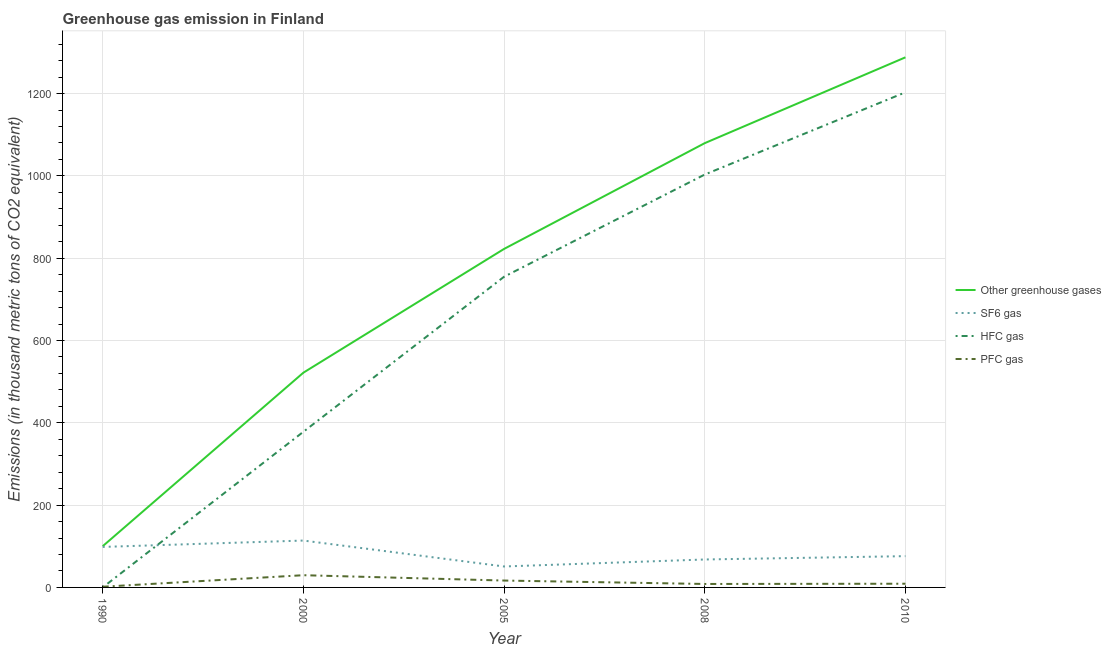What is the emission of pfc gas in 2000?
Provide a succinct answer. 29.7. Across all years, what is the maximum emission of hfc gas?
Your response must be concise. 1203. Across all years, what is the minimum emission of greenhouse gases?
Give a very brief answer. 100.2. What is the total emission of greenhouse gases in the graph?
Ensure brevity in your answer.  3812. What is the difference between the emission of pfc gas in 2000 and that in 2008?
Provide a short and direct response. 21.3. What is the difference between the emission of greenhouse gases in 2005 and the emission of pfc gas in 2008?
Keep it short and to the point. 814.1. In the year 1990, what is the difference between the emission of hfc gas and emission of pfc gas?
Provide a succinct answer. -1.6. What is the ratio of the emission of hfc gas in 1990 to that in 2008?
Your response must be concise. 9.968102073365231e-5. What is the difference between the highest and the second highest emission of greenhouse gases?
Give a very brief answer. 208.5. What is the difference between the highest and the lowest emission of hfc gas?
Provide a short and direct response. 1202.9. In how many years, is the emission of hfc gas greater than the average emission of hfc gas taken over all years?
Offer a terse response. 3. Is it the case that in every year, the sum of the emission of greenhouse gases and emission of sf6 gas is greater than the emission of hfc gas?
Your answer should be compact. Yes. Does the emission of pfc gas monotonically increase over the years?
Keep it short and to the point. No. Is the emission of pfc gas strictly less than the emission of sf6 gas over the years?
Ensure brevity in your answer.  Yes. How many years are there in the graph?
Your answer should be very brief. 5. Where does the legend appear in the graph?
Your answer should be very brief. Center right. How many legend labels are there?
Your answer should be compact. 4. What is the title of the graph?
Ensure brevity in your answer.  Greenhouse gas emission in Finland. What is the label or title of the Y-axis?
Offer a very short reply. Emissions (in thousand metric tons of CO2 equivalent). What is the Emissions (in thousand metric tons of CO2 equivalent) of Other greenhouse gases in 1990?
Provide a short and direct response. 100.2. What is the Emissions (in thousand metric tons of CO2 equivalent) of SF6 gas in 1990?
Give a very brief answer. 98.4. What is the Emissions (in thousand metric tons of CO2 equivalent) in Other greenhouse gases in 2000?
Ensure brevity in your answer.  521.8. What is the Emissions (in thousand metric tons of CO2 equivalent) in SF6 gas in 2000?
Make the answer very short. 113.9. What is the Emissions (in thousand metric tons of CO2 equivalent) in HFC gas in 2000?
Give a very brief answer. 378.2. What is the Emissions (in thousand metric tons of CO2 equivalent) of PFC gas in 2000?
Your response must be concise. 29.7. What is the Emissions (in thousand metric tons of CO2 equivalent) in Other greenhouse gases in 2005?
Offer a very short reply. 822.5. What is the Emissions (in thousand metric tons of CO2 equivalent) in SF6 gas in 2005?
Your answer should be compact. 50.9. What is the Emissions (in thousand metric tons of CO2 equivalent) in HFC gas in 2005?
Provide a succinct answer. 754.9. What is the Emissions (in thousand metric tons of CO2 equivalent) in PFC gas in 2005?
Keep it short and to the point. 16.7. What is the Emissions (in thousand metric tons of CO2 equivalent) in Other greenhouse gases in 2008?
Provide a short and direct response. 1079.5. What is the Emissions (in thousand metric tons of CO2 equivalent) in SF6 gas in 2008?
Offer a very short reply. 67.9. What is the Emissions (in thousand metric tons of CO2 equivalent) of HFC gas in 2008?
Provide a succinct answer. 1003.2. What is the Emissions (in thousand metric tons of CO2 equivalent) of PFC gas in 2008?
Ensure brevity in your answer.  8.4. What is the Emissions (in thousand metric tons of CO2 equivalent) of Other greenhouse gases in 2010?
Your answer should be very brief. 1288. What is the Emissions (in thousand metric tons of CO2 equivalent) in SF6 gas in 2010?
Give a very brief answer. 76. What is the Emissions (in thousand metric tons of CO2 equivalent) in HFC gas in 2010?
Keep it short and to the point. 1203. What is the Emissions (in thousand metric tons of CO2 equivalent) of PFC gas in 2010?
Provide a short and direct response. 9. Across all years, what is the maximum Emissions (in thousand metric tons of CO2 equivalent) of Other greenhouse gases?
Provide a short and direct response. 1288. Across all years, what is the maximum Emissions (in thousand metric tons of CO2 equivalent) of SF6 gas?
Provide a short and direct response. 113.9. Across all years, what is the maximum Emissions (in thousand metric tons of CO2 equivalent) in HFC gas?
Ensure brevity in your answer.  1203. Across all years, what is the maximum Emissions (in thousand metric tons of CO2 equivalent) of PFC gas?
Keep it short and to the point. 29.7. Across all years, what is the minimum Emissions (in thousand metric tons of CO2 equivalent) in Other greenhouse gases?
Offer a very short reply. 100.2. Across all years, what is the minimum Emissions (in thousand metric tons of CO2 equivalent) of SF6 gas?
Ensure brevity in your answer.  50.9. Across all years, what is the minimum Emissions (in thousand metric tons of CO2 equivalent) in HFC gas?
Offer a terse response. 0.1. What is the total Emissions (in thousand metric tons of CO2 equivalent) in Other greenhouse gases in the graph?
Your answer should be compact. 3812. What is the total Emissions (in thousand metric tons of CO2 equivalent) of SF6 gas in the graph?
Your response must be concise. 407.1. What is the total Emissions (in thousand metric tons of CO2 equivalent) of HFC gas in the graph?
Ensure brevity in your answer.  3339.4. What is the total Emissions (in thousand metric tons of CO2 equivalent) of PFC gas in the graph?
Your answer should be compact. 65.5. What is the difference between the Emissions (in thousand metric tons of CO2 equivalent) in Other greenhouse gases in 1990 and that in 2000?
Offer a very short reply. -421.6. What is the difference between the Emissions (in thousand metric tons of CO2 equivalent) of SF6 gas in 1990 and that in 2000?
Offer a terse response. -15.5. What is the difference between the Emissions (in thousand metric tons of CO2 equivalent) of HFC gas in 1990 and that in 2000?
Provide a succinct answer. -378.1. What is the difference between the Emissions (in thousand metric tons of CO2 equivalent) in PFC gas in 1990 and that in 2000?
Offer a terse response. -28. What is the difference between the Emissions (in thousand metric tons of CO2 equivalent) of Other greenhouse gases in 1990 and that in 2005?
Offer a very short reply. -722.3. What is the difference between the Emissions (in thousand metric tons of CO2 equivalent) of SF6 gas in 1990 and that in 2005?
Offer a very short reply. 47.5. What is the difference between the Emissions (in thousand metric tons of CO2 equivalent) of HFC gas in 1990 and that in 2005?
Provide a succinct answer. -754.8. What is the difference between the Emissions (in thousand metric tons of CO2 equivalent) of Other greenhouse gases in 1990 and that in 2008?
Offer a very short reply. -979.3. What is the difference between the Emissions (in thousand metric tons of CO2 equivalent) in SF6 gas in 1990 and that in 2008?
Ensure brevity in your answer.  30.5. What is the difference between the Emissions (in thousand metric tons of CO2 equivalent) of HFC gas in 1990 and that in 2008?
Your response must be concise. -1003.1. What is the difference between the Emissions (in thousand metric tons of CO2 equivalent) in PFC gas in 1990 and that in 2008?
Give a very brief answer. -6.7. What is the difference between the Emissions (in thousand metric tons of CO2 equivalent) of Other greenhouse gases in 1990 and that in 2010?
Your answer should be compact. -1187.8. What is the difference between the Emissions (in thousand metric tons of CO2 equivalent) of SF6 gas in 1990 and that in 2010?
Provide a short and direct response. 22.4. What is the difference between the Emissions (in thousand metric tons of CO2 equivalent) of HFC gas in 1990 and that in 2010?
Keep it short and to the point. -1202.9. What is the difference between the Emissions (in thousand metric tons of CO2 equivalent) in Other greenhouse gases in 2000 and that in 2005?
Give a very brief answer. -300.7. What is the difference between the Emissions (in thousand metric tons of CO2 equivalent) of SF6 gas in 2000 and that in 2005?
Your answer should be very brief. 63. What is the difference between the Emissions (in thousand metric tons of CO2 equivalent) of HFC gas in 2000 and that in 2005?
Offer a very short reply. -376.7. What is the difference between the Emissions (in thousand metric tons of CO2 equivalent) of Other greenhouse gases in 2000 and that in 2008?
Provide a short and direct response. -557.7. What is the difference between the Emissions (in thousand metric tons of CO2 equivalent) of HFC gas in 2000 and that in 2008?
Your response must be concise. -625. What is the difference between the Emissions (in thousand metric tons of CO2 equivalent) in PFC gas in 2000 and that in 2008?
Offer a terse response. 21.3. What is the difference between the Emissions (in thousand metric tons of CO2 equivalent) of Other greenhouse gases in 2000 and that in 2010?
Give a very brief answer. -766.2. What is the difference between the Emissions (in thousand metric tons of CO2 equivalent) of SF6 gas in 2000 and that in 2010?
Your response must be concise. 37.9. What is the difference between the Emissions (in thousand metric tons of CO2 equivalent) in HFC gas in 2000 and that in 2010?
Give a very brief answer. -824.8. What is the difference between the Emissions (in thousand metric tons of CO2 equivalent) of PFC gas in 2000 and that in 2010?
Your answer should be compact. 20.7. What is the difference between the Emissions (in thousand metric tons of CO2 equivalent) of Other greenhouse gases in 2005 and that in 2008?
Your answer should be very brief. -257. What is the difference between the Emissions (in thousand metric tons of CO2 equivalent) of HFC gas in 2005 and that in 2008?
Your answer should be compact. -248.3. What is the difference between the Emissions (in thousand metric tons of CO2 equivalent) in PFC gas in 2005 and that in 2008?
Provide a short and direct response. 8.3. What is the difference between the Emissions (in thousand metric tons of CO2 equivalent) in Other greenhouse gases in 2005 and that in 2010?
Ensure brevity in your answer.  -465.5. What is the difference between the Emissions (in thousand metric tons of CO2 equivalent) in SF6 gas in 2005 and that in 2010?
Your answer should be compact. -25.1. What is the difference between the Emissions (in thousand metric tons of CO2 equivalent) of HFC gas in 2005 and that in 2010?
Offer a terse response. -448.1. What is the difference between the Emissions (in thousand metric tons of CO2 equivalent) of PFC gas in 2005 and that in 2010?
Provide a short and direct response. 7.7. What is the difference between the Emissions (in thousand metric tons of CO2 equivalent) in Other greenhouse gases in 2008 and that in 2010?
Your answer should be very brief. -208.5. What is the difference between the Emissions (in thousand metric tons of CO2 equivalent) of HFC gas in 2008 and that in 2010?
Offer a very short reply. -199.8. What is the difference between the Emissions (in thousand metric tons of CO2 equivalent) in PFC gas in 2008 and that in 2010?
Give a very brief answer. -0.6. What is the difference between the Emissions (in thousand metric tons of CO2 equivalent) of Other greenhouse gases in 1990 and the Emissions (in thousand metric tons of CO2 equivalent) of SF6 gas in 2000?
Offer a terse response. -13.7. What is the difference between the Emissions (in thousand metric tons of CO2 equivalent) of Other greenhouse gases in 1990 and the Emissions (in thousand metric tons of CO2 equivalent) of HFC gas in 2000?
Your answer should be compact. -278. What is the difference between the Emissions (in thousand metric tons of CO2 equivalent) of Other greenhouse gases in 1990 and the Emissions (in thousand metric tons of CO2 equivalent) of PFC gas in 2000?
Provide a succinct answer. 70.5. What is the difference between the Emissions (in thousand metric tons of CO2 equivalent) in SF6 gas in 1990 and the Emissions (in thousand metric tons of CO2 equivalent) in HFC gas in 2000?
Your answer should be compact. -279.8. What is the difference between the Emissions (in thousand metric tons of CO2 equivalent) in SF6 gas in 1990 and the Emissions (in thousand metric tons of CO2 equivalent) in PFC gas in 2000?
Ensure brevity in your answer.  68.7. What is the difference between the Emissions (in thousand metric tons of CO2 equivalent) in HFC gas in 1990 and the Emissions (in thousand metric tons of CO2 equivalent) in PFC gas in 2000?
Provide a succinct answer. -29.6. What is the difference between the Emissions (in thousand metric tons of CO2 equivalent) of Other greenhouse gases in 1990 and the Emissions (in thousand metric tons of CO2 equivalent) of SF6 gas in 2005?
Provide a short and direct response. 49.3. What is the difference between the Emissions (in thousand metric tons of CO2 equivalent) in Other greenhouse gases in 1990 and the Emissions (in thousand metric tons of CO2 equivalent) in HFC gas in 2005?
Your response must be concise. -654.7. What is the difference between the Emissions (in thousand metric tons of CO2 equivalent) of Other greenhouse gases in 1990 and the Emissions (in thousand metric tons of CO2 equivalent) of PFC gas in 2005?
Offer a terse response. 83.5. What is the difference between the Emissions (in thousand metric tons of CO2 equivalent) in SF6 gas in 1990 and the Emissions (in thousand metric tons of CO2 equivalent) in HFC gas in 2005?
Offer a terse response. -656.5. What is the difference between the Emissions (in thousand metric tons of CO2 equivalent) of SF6 gas in 1990 and the Emissions (in thousand metric tons of CO2 equivalent) of PFC gas in 2005?
Make the answer very short. 81.7. What is the difference between the Emissions (in thousand metric tons of CO2 equivalent) in HFC gas in 1990 and the Emissions (in thousand metric tons of CO2 equivalent) in PFC gas in 2005?
Your answer should be compact. -16.6. What is the difference between the Emissions (in thousand metric tons of CO2 equivalent) in Other greenhouse gases in 1990 and the Emissions (in thousand metric tons of CO2 equivalent) in SF6 gas in 2008?
Offer a very short reply. 32.3. What is the difference between the Emissions (in thousand metric tons of CO2 equivalent) in Other greenhouse gases in 1990 and the Emissions (in thousand metric tons of CO2 equivalent) in HFC gas in 2008?
Provide a succinct answer. -903. What is the difference between the Emissions (in thousand metric tons of CO2 equivalent) of Other greenhouse gases in 1990 and the Emissions (in thousand metric tons of CO2 equivalent) of PFC gas in 2008?
Your response must be concise. 91.8. What is the difference between the Emissions (in thousand metric tons of CO2 equivalent) of SF6 gas in 1990 and the Emissions (in thousand metric tons of CO2 equivalent) of HFC gas in 2008?
Provide a succinct answer. -904.8. What is the difference between the Emissions (in thousand metric tons of CO2 equivalent) of HFC gas in 1990 and the Emissions (in thousand metric tons of CO2 equivalent) of PFC gas in 2008?
Keep it short and to the point. -8.3. What is the difference between the Emissions (in thousand metric tons of CO2 equivalent) of Other greenhouse gases in 1990 and the Emissions (in thousand metric tons of CO2 equivalent) of SF6 gas in 2010?
Offer a very short reply. 24.2. What is the difference between the Emissions (in thousand metric tons of CO2 equivalent) in Other greenhouse gases in 1990 and the Emissions (in thousand metric tons of CO2 equivalent) in HFC gas in 2010?
Offer a terse response. -1102.8. What is the difference between the Emissions (in thousand metric tons of CO2 equivalent) of Other greenhouse gases in 1990 and the Emissions (in thousand metric tons of CO2 equivalent) of PFC gas in 2010?
Provide a succinct answer. 91.2. What is the difference between the Emissions (in thousand metric tons of CO2 equivalent) of SF6 gas in 1990 and the Emissions (in thousand metric tons of CO2 equivalent) of HFC gas in 2010?
Give a very brief answer. -1104.6. What is the difference between the Emissions (in thousand metric tons of CO2 equivalent) in SF6 gas in 1990 and the Emissions (in thousand metric tons of CO2 equivalent) in PFC gas in 2010?
Your answer should be compact. 89.4. What is the difference between the Emissions (in thousand metric tons of CO2 equivalent) in HFC gas in 1990 and the Emissions (in thousand metric tons of CO2 equivalent) in PFC gas in 2010?
Your answer should be very brief. -8.9. What is the difference between the Emissions (in thousand metric tons of CO2 equivalent) in Other greenhouse gases in 2000 and the Emissions (in thousand metric tons of CO2 equivalent) in SF6 gas in 2005?
Offer a terse response. 470.9. What is the difference between the Emissions (in thousand metric tons of CO2 equivalent) in Other greenhouse gases in 2000 and the Emissions (in thousand metric tons of CO2 equivalent) in HFC gas in 2005?
Ensure brevity in your answer.  -233.1. What is the difference between the Emissions (in thousand metric tons of CO2 equivalent) in Other greenhouse gases in 2000 and the Emissions (in thousand metric tons of CO2 equivalent) in PFC gas in 2005?
Make the answer very short. 505.1. What is the difference between the Emissions (in thousand metric tons of CO2 equivalent) of SF6 gas in 2000 and the Emissions (in thousand metric tons of CO2 equivalent) of HFC gas in 2005?
Provide a succinct answer. -641. What is the difference between the Emissions (in thousand metric tons of CO2 equivalent) in SF6 gas in 2000 and the Emissions (in thousand metric tons of CO2 equivalent) in PFC gas in 2005?
Offer a very short reply. 97.2. What is the difference between the Emissions (in thousand metric tons of CO2 equivalent) in HFC gas in 2000 and the Emissions (in thousand metric tons of CO2 equivalent) in PFC gas in 2005?
Make the answer very short. 361.5. What is the difference between the Emissions (in thousand metric tons of CO2 equivalent) of Other greenhouse gases in 2000 and the Emissions (in thousand metric tons of CO2 equivalent) of SF6 gas in 2008?
Make the answer very short. 453.9. What is the difference between the Emissions (in thousand metric tons of CO2 equivalent) in Other greenhouse gases in 2000 and the Emissions (in thousand metric tons of CO2 equivalent) in HFC gas in 2008?
Ensure brevity in your answer.  -481.4. What is the difference between the Emissions (in thousand metric tons of CO2 equivalent) in Other greenhouse gases in 2000 and the Emissions (in thousand metric tons of CO2 equivalent) in PFC gas in 2008?
Offer a very short reply. 513.4. What is the difference between the Emissions (in thousand metric tons of CO2 equivalent) in SF6 gas in 2000 and the Emissions (in thousand metric tons of CO2 equivalent) in HFC gas in 2008?
Your answer should be very brief. -889.3. What is the difference between the Emissions (in thousand metric tons of CO2 equivalent) in SF6 gas in 2000 and the Emissions (in thousand metric tons of CO2 equivalent) in PFC gas in 2008?
Your response must be concise. 105.5. What is the difference between the Emissions (in thousand metric tons of CO2 equivalent) of HFC gas in 2000 and the Emissions (in thousand metric tons of CO2 equivalent) of PFC gas in 2008?
Give a very brief answer. 369.8. What is the difference between the Emissions (in thousand metric tons of CO2 equivalent) in Other greenhouse gases in 2000 and the Emissions (in thousand metric tons of CO2 equivalent) in SF6 gas in 2010?
Ensure brevity in your answer.  445.8. What is the difference between the Emissions (in thousand metric tons of CO2 equivalent) in Other greenhouse gases in 2000 and the Emissions (in thousand metric tons of CO2 equivalent) in HFC gas in 2010?
Your answer should be very brief. -681.2. What is the difference between the Emissions (in thousand metric tons of CO2 equivalent) in Other greenhouse gases in 2000 and the Emissions (in thousand metric tons of CO2 equivalent) in PFC gas in 2010?
Offer a very short reply. 512.8. What is the difference between the Emissions (in thousand metric tons of CO2 equivalent) of SF6 gas in 2000 and the Emissions (in thousand metric tons of CO2 equivalent) of HFC gas in 2010?
Make the answer very short. -1089.1. What is the difference between the Emissions (in thousand metric tons of CO2 equivalent) of SF6 gas in 2000 and the Emissions (in thousand metric tons of CO2 equivalent) of PFC gas in 2010?
Ensure brevity in your answer.  104.9. What is the difference between the Emissions (in thousand metric tons of CO2 equivalent) of HFC gas in 2000 and the Emissions (in thousand metric tons of CO2 equivalent) of PFC gas in 2010?
Provide a succinct answer. 369.2. What is the difference between the Emissions (in thousand metric tons of CO2 equivalent) in Other greenhouse gases in 2005 and the Emissions (in thousand metric tons of CO2 equivalent) in SF6 gas in 2008?
Your answer should be very brief. 754.6. What is the difference between the Emissions (in thousand metric tons of CO2 equivalent) of Other greenhouse gases in 2005 and the Emissions (in thousand metric tons of CO2 equivalent) of HFC gas in 2008?
Provide a short and direct response. -180.7. What is the difference between the Emissions (in thousand metric tons of CO2 equivalent) in Other greenhouse gases in 2005 and the Emissions (in thousand metric tons of CO2 equivalent) in PFC gas in 2008?
Your answer should be very brief. 814.1. What is the difference between the Emissions (in thousand metric tons of CO2 equivalent) of SF6 gas in 2005 and the Emissions (in thousand metric tons of CO2 equivalent) of HFC gas in 2008?
Your response must be concise. -952.3. What is the difference between the Emissions (in thousand metric tons of CO2 equivalent) of SF6 gas in 2005 and the Emissions (in thousand metric tons of CO2 equivalent) of PFC gas in 2008?
Offer a terse response. 42.5. What is the difference between the Emissions (in thousand metric tons of CO2 equivalent) of HFC gas in 2005 and the Emissions (in thousand metric tons of CO2 equivalent) of PFC gas in 2008?
Your answer should be very brief. 746.5. What is the difference between the Emissions (in thousand metric tons of CO2 equivalent) in Other greenhouse gases in 2005 and the Emissions (in thousand metric tons of CO2 equivalent) in SF6 gas in 2010?
Offer a very short reply. 746.5. What is the difference between the Emissions (in thousand metric tons of CO2 equivalent) of Other greenhouse gases in 2005 and the Emissions (in thousand metric tons of CO2 equivalent) of HFC gas in 2010?
Provide a succinct answer. -380.5. What is the difference between the Emissions (in thousand metric tons of CO2 equivalent) of Other greenhouse gases in 2005 and the Emissions (in thousand metric tons of CO2 equivalent) of PFC gas in 2010?
Make the answer very short. 813.5. What is the difference between the Emissions (in thousand metric tons of CO2 equivalent) of SF6 gas in 2005 and the Emissions (in thousand metric tons of CO2 equivalent) of HFC gas in 2010?
Offer a very short reply. -1152.1. What is the difference between the Emissions (in thousand metric tons of CO2 equivalent) of SF6 gas in 2005 and the Emissions (in thousand metric tons of CO2 equivalent) of PFC gas in 2010?
Your answer should be compact. 41.9. What is the difference between the Emissions (in thousand metric tons of CO2 equivalent) of HFC gas in 2005 and the Emissions (in thousand metric tons of CO2 equivalent) of PFC gas in 2010?
Provide a succinct answer. 745.9. What is the difference between the Emissions (in thousand metric tons of CO2 equivalent) of Other greenhouse gases in 2008 and the Emissions (in thousand metric tons of CO2 equivalent) of SF6 gas in 2010?
Your answer should be compact. 1003.5. What is the difference between the Emissions (in thousand metric tons of CO2 equivalent) in Other greenhouse gases in 2008 and the Emissions (in thousand metric tons of CO2 equivalent) in HFC gas in 2010?
Keep it short and to the point. -123.5. What is the difference between the Emissions (in thousand metric tons of CO2 equivalent) in Other greenhouse gases in 2008 and the Emissions (in thousand metric tons of CO2 equivalent) in PFC gas in 2010?
Your answer should be very brief. 1070.5. What is the difference between the Emissions (in thousand metric tons of CO2 equivalent) in SF6 gas in 2008 and the Emissions (in thousand metric tons of CO2 equivalent) in HFC gas in 2010?
Ensure brevity in your answer.  -1135.1. What is the difference between the Emissions (in thousand metric tons of CO2 equivalent) of SF6 gas in 2008 and the Emissions (in thousand metric tons of CO2 equivalent) of PFC gas in 2010?
Provide a short and direct response. 58.9. What is the difference between the Emissions (in thousand metric tons of CO2 equivalent) of HFC gas in 2008 and the Emissions (in thousand metric tons of CO2 equivalent) of PFC gas in 2010?
Offer a very short reply. 994.2. What is the average Emissions (in thousand metric tons of CO2 equivalent) in Other greenhouse gases per year?
Your response must be concise. 762.4. What is the average Emissions (in thousand metric tons of CO2 equivalent) in SF6 gas per year?
Offer a terse response. 81.42. What is the average Emissions (in thousand metric tons of CO2 equivalent) of HFC gas per year?
Ensure brevity in your answer.  667.88. In the year 1990, what is the difference between the Emissions (in thousand metric tons of CO2 equivalent) in Other greenhouse gases and Emissions (in thousand metric tons of CO2 equivalent) in SF6 gas?
Provide a succinct answer. 1.8. In the year 1990, what is the difference between the Emissions (in thousand metric tons of CO2 equivalent) in Other greenhouse gases and Emissions (in thousand metric tons of CO2 equivalent) in HFC gas?
Offer a terse response. 100.1. In the year 1990, what is the difference between the Emissions (in thousand metric tons of CO2 equivalent) in Other greenhouse gases and Emissions (in thousand metric tons of CO2 equivalent) in PFC gas?
Make the answer very short. 98.5. In the year 1990, what is the difference between the Emissions (in thousand metric tons of CO2 equivalent) in SF6 gas and Emissions (in thousand metric tons of CO2 equivalent) in HFC gas?
Provide a short and direct response. 98.3. In the year 1990, what is the difference between the Emissions (in thousand metric tons of CO2 equivalent) in SF6 gas and Emissions (in thousand metric tons of CO2 equivalent) in PFC gas?
Provide a short and direct response. 96.7. In the year 1990, what is the difference between the Emissions (in thousand metric tons of CO2 equivalent) in HFC gas and Emissions (in thousand metric tons of CO2 equivalent) in PFC gas?
Give a very brief answer. -1.6. In the year 2000, what is the difference between the Emissions (in thousand metric tons of CO2 equivalent) of Other greenhouse gases and Emissions (in thousand metric tons of CO2 equivalent) of SF6 gas?
Provide a short and direct response. 407.9. In the year 2000, what is the difference between the Emissions (in thousand metric tons of CO2 equivalent) of Other greenhouse gases and Emissions (in thousand metric tons of CO2 equivalent) of HFC gas?
Your answer should be very brief. 143.6. In the year 2000, what is the difference between the Emissions (in thousand metric tons of CO2 equivalent) of Other greenhouse gases and Emissions (in thousand metric tons of CO2 equivalent) of PFC gas?
Make the answer very short. 492.1. In the year 2000, what is the difference between the Emissions (in thousand metric tons of CO2 equivalent) in SF6 gas and Emissions (in thousand metric tons of CO2 equivalent) in HFC gas?
Ensure brevity in your answer.  -264.3. In the year 2000, what is the difference between the Emissions (in thousand metric tons of CO2 equivalent) of SF6 gas and Emissions (in thousand metric tons of CO2 equivalent) of PFC gas?
Give a very brief answer. 84.2. In the year 2000, what is the difference between the Emissions (in thousand metric tons of CO2 equivalent) in HFC gas and Emissions (in thousand metric tons of CO2 equivalent) in PFC gas?
Offer a very short reply. 348.5. In the year 2005, what is the difference between the Emissions (in thousand metric tons of CO2 equivalent) in Other greenhouse gases and Emissions (in thousand metric tons of CO2 equivalent) in SF6 gas?
Offer a terse response. 771.6. In the year 2005, what is the difference between the Emissions (in thousand metric tons of CO2 equivalent) in Other greenhouse gases and Emissions (in thousand metric tons of CO2 equivalent) in HFC gas?
Give a very brief answer. 67.6. In the year 2005, what is the difference between the Emissions (in thousand metric tons of CO2 equivalent) in Other greenhouse gases and Emissions (in thousand metric tons of CO2 equivalent) in PFC gas?
Your answer should be compact. 805.8. In the year 2005, what is the difference between the Emissions (in thousand metric tons of CO2 equivalent) of SF6 gas and Emissions (in thousand metric tons of CO2 equivalent) of HFC gas?
Ensure brevity in your answer.  -704. In the year 2005, what is the difference between the Emissions (in thousand metric tons of CO2 equivalent) of SF6 gas and Emissions (in thousand metric tons of CO2 equivalent) of PFC gas?
Your answer should be very brief. 34.2. In the year 2005, what is the difference between the Emissions (in thousand metric tons of CO2 equivalent) of HFC gas and Emissions (in thousand metric tons of CO2 equivalent) of PFC gas?
Ensure brevity in your answer.  738.2. In the year 2008, what is the difference between the Emissions (in thousand metric tons of CO2 equivalent) of Other greenhouse gases and Emissions (in thousand metric tons of CO2 equivalent) of SF6 gas?
Provide a short and direct response. 1011.6. In the year 2008, what is the difference between the Emissions (in thousand metric tons of CO2 equivalent) of Other greenhouse gases and Emissions (in thousand metric tons of CO2 equivalent) of HFC gas?
Offer a terse response. 76.3. In the year 2008, what is the difference between the Emissions (in thousand metric tons of CO2 equivalent) of Other greenhouse gases and Emissions (in thousand metric tons of CO2 equivalent) of PFC gas?
Give a very brief answer. 1071.1. In the year 2008, what is the difference between the Emissions (in thousand metric tons of CO2 equivalent) in SF6 gas and Emissions (in thousand metric tons of CO2 equivalent) in HFC gas?
Your answer should be compact. -935.3. In the year 2008, what is the difference between the Emissions (in thousand metric tons of CO2 equivalent) of SF6 gas and Emissions (in thousand metric tons of CO2 equivalent) of PFC gas?
Your answer should be compact. 59.5. In the year 2008, what is the difference between the Emissions (in thousand metric tons of CO2 equivalent) in HFC gas and Emissions (in thousand metric tons of CO2 equivalent) in PFC gas?
Provide a short and direct response. 994.8. In the year 2010, what is the difference between the Emissions (in thousand metric tons of CO2 equivalent) in Other greenhouse gases and Emissions (in thousand metric tons of CO2 equivalent) in SF6 gas?
Offer a very short reply. 1212. In the year 2010, what is the difference between the Emissions (in thousand metric tons of CO2 equivalent) of Other greenhouse gases and Emissions (in thousand metric tons of CO2 equivalent) of PFC gas?
Your answer should be compact. 1279. In the year 2010, what is the difference between the Emissions (in thousand metric tons of CO2 equivalent) of SF6 gas and Emissions (in thousand metric tons of CO2 equivalent) of HFC gas?
Your response must be concise. -1127. In the year 2010, what is the difference between the Emissions (in thousand metric tons of CO2 equivalent) of HFC gas and Emissions (in thousand metric tons of CO2 equivalent) of PFC gas?
Your answer should be compact. 1194. What is the ratio of the Emissions (in thousand metric tons of CO2 equivalent) in Other greenhouse gases in 1990 to that in 2000?
Your answer should be very brief. 0.19. What is the ratio of the Emissions (in thousand metric tons of CO2 equivalent) in SF6 gas in 1990 to that in 2000?
Ensure brevity in your answer.  0.86. What is the ratio of the Emissions (in thousand metric tons of CO2 equivalent) of HFC gas in 1990 to that in 2000?
Your response must be concise. 0. What is the ratio of the Emissions (in thousand metric tons of CO2 equivalent) of PFC gas in 1990 to that in 2000?
Give a very brief answer. 0.06. What is the ratio of the Emissions (in thousand metric tons of CO2 equivalent) in Other greenhouse gases in 1990 to that in 2005?
Ensure brevity in your answer.  0.12. What is the ratio of the Emissions (in thousand metric tons of CO2 equivalent) in SF6 gas in 1990 to that in 2005?
Your answer should be very brief. 1.93. What is the ratio of the Emissions (in thousand metric tons of CO2 equivalent) in HFC gas in 1990 to that in 2005?
Give a very brief answer. 0. What is the ratio of the Emissions (in thousand metric tons of CO2 equivalent) of PFC gas in 1990 to that in 2005?
Offer a very short reply. 0.1. What is the ratio of the Emissions (in thousand metric tons of CO2 equivalent) of Other greenhouse gases in 1990 to that in 2008?
Your answer should be very brief. 0.09. What is the ratio of the Emissions (in thousand metric tons of CO2 equivalent) of SF6 gas in 1990 to that in 2008?
Your answer should be very brief. 1.45. What is the ratio of the Emissions (in thousand metric tons of CO2 equivalent) in PFC gas in 1990 to that in 2008?
Provide a short and direct response. 0.2. What is the ratio of the Emissions (in thousand metric tons of CO2 equivalent) of Other greenhouse gases in 1990 to that in 2010?
Offer a very short reply. 0.08. What is the ratio of the Emissions (in thousand metric tons of CO2 equivalent) in SF6 gas in 1990 to that in 2010?
Provide a short and direct response. 1.29. What is the ratio of the Emissions (in thousand metric tons of CO2 equivalent) of HFC gas in 1990 to that in 2010?
Give a very brief answer. 0. What is the ratio of the Emissions (in thousand metric tons of CO2 equivalent) in PFC gas in 1990 to that in 2010?
Provide a succinct answer. 0.19. What is the ratio of the Emissions (in thousand metric tons of CO2 equivalent) in Other greenhouse gases in 2000 to that in 2005?
Keep it short and to the point. 0.63. What is the ratio of the Emissions (in thousand metric tons of CO2 equivalent) in SF6 gas in 2000 to that in 2005?
Give a very brief answer. 2.24. What is the ratio of the Emissions (in thousand metric tons of CO2 equivalent) in HFC gas in 2000 to that in 2005?
Keep it short and to the point. 0.5. What is the ratio of the Emissions (in thousand metric tons of CO2 equivalent) in PFC gas in 2000 to that in 2005?
Make the answer very short. 1.78. What is the ratio of the Emissions (in thousand metric tons of CO2 equivalent) of Other greenhouse gases in 2000 to that in 2008?
Give a very brief answer. 0.48. What is the ratio of the Emissions (in thousand metric tons of CO2 equivalent) of SF6 gas in 2000 to that in 2008?
Offer a terse response. 1.68. What is the ratio of the Emissions (in thousand metric tons of CO2 equivalent) of HFC gas in 2000 to that in 2008?
Keep it short and to the point. 0.38. What is the ratio of the Emissions (in thousand metric tons of CO2 equivalent) of PFC gas in 2000 to that in 2008?
Provide a short and direct response. 3.54. What is the ratio of the Emissions (in thousand metric tons of CO2 equivalent) in Other greenhouse gases in 2000 to that in 2010?
Provide a succinct answer. 0.41. What is the ratio of the Emissions (in thousand metric tons of CO2 equivalent) in SF6 gas in 2000 to that in 2010?
Your answer should be compact. 1.5. What is the ratio of the Emissions (in thousand metric tons of CO2 equivalent) in HFC gas in 2000 to that in 2010?
Your answer should be very brief. 0.31. What is the ratio of the Emissions (in thousand metric tons of CO2 equivalent) in PFC gas in 2000 to that in 2010?
Offer a very short reply. 3.3. What is the ratio of the Emissions (in thousand metric tons of CO2 equivalent) in Other greenhouse gases in 2005 to that in 2008?
Your answer should be very brief. 0.76. What is the ratio of the Emissions (in thousand metric tons of CO2 equivalent) of SF6 gas in 2005 to that in 2008?
Your answer should be compact. 0.75. What is the ratio of the Emissions (in thousand metric tons of CO2 equivalent) in HFC gas in 2005 to that in 2008?
Give a very brief answer. 0.75. What is the ratio of the Emissions (in thousand metric tons of CO2 equivalent) in PFC gas in 2005 to that in 2008?
Provide a short and direct response. 1.99. What is the ratio of the Emissions (in thousand metric tons of CO2 equivalent) in Other greenhouse gases in 2005 to that in 2010?
Keep it short and to the point. 0.64. What is the ratio of the Emissions (in thousand metric tons of CO2 equivalent) in SF6 gas in 2005 to that in 2010?
Offer a very short reply. 0.67. What is the ratio of the Emissions (in thousand metric tons of CO2 equivalent) of HFC gas in 2005 to that in 2010?
Your answer should be very brief. 0.63. What is the ratio of the Emissions (in thousand metric tons of CO2 equivalent) in PFC gas in 2005 to that in 2010?
Offer a very short reply. 1.86. What is the ratio of the Emissions (in thousand metric tons of CO2 equivalent) in Other greenhouse gases in 2008 to that in 2010?
Provide a succinct answer. 0.84. What is the ratio of the Emissions (in thousand metric tons of CO2 equivalent) in SF6 gas in 2008 to that in 2010?
Your response must be concise. 0.89. What is the ratio of the Emissions (in thousand metric tons of CO2 equivalent) in HFC gas in 2008 to that in 2010?
Offer a terse response. 0.83. What is the difference between the highest and the second highest Emissions (in thousand metric tons of CO2 equivalent) of Other greenhouse gases?
Your answer should be compact. 208.5. What is the difference between the highest and the second highest Emissions (in thousand metric tons of CO2 equivalent) of SF6 gas?
Give a very brief answer. 15.5. What is the difference between the highest and the second highest Emissions (in thousand metric tons of CO2 equivalent) of HFC gas?
Your answer should be very brief. 199.8. What is the difference between the highest and the lowest Emissions (in thousand metric tons of CO2 equivalent) in Other greenhouse gases?
Make the answer very short. 1187.8. What is the difference between the highest and the lowest Emissions (in thousand metric tons of CO2 equivalent) in SF6 gas?
Give a very brief answer. 63. What is the difference between the highest and the lowest Emissions (in thousand metric tons of CO2 equivalent) of HFC gas?
Your answer should be compact. 1202.9. 